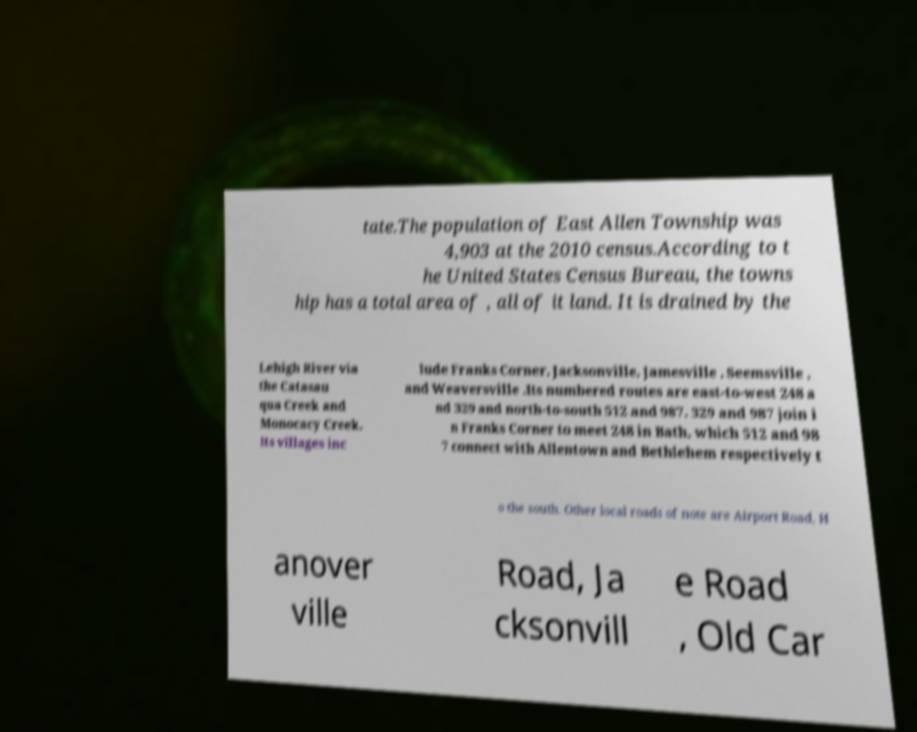For documentation purposes, I need the text within this image transcribed. Could you provide that? tate.The population of East Allen Township was 4,903 at the 2010 census.According to t he United States Census Bureau, the towns hip has a total area of , all of it land. It is drained by the Lehigh River via the Catasau qua Creek and Monocacy Creek. Its villages inc lude Franks Corner, Jacksonville, Jamesville , Seemsville , and Weaversville .Its numbered routes are east-to-west 248 a nd 329 and north-to-south 512 and 987. 329 and 987 join i n Franks Corner to meet 248 in Bath, which 512 and 98 7 connect with Allentown and Bethlehem respectively t o the south. Other local roads of note are Airport Road, H anover ville Road, Ja cksonvill e Road , Old Car 